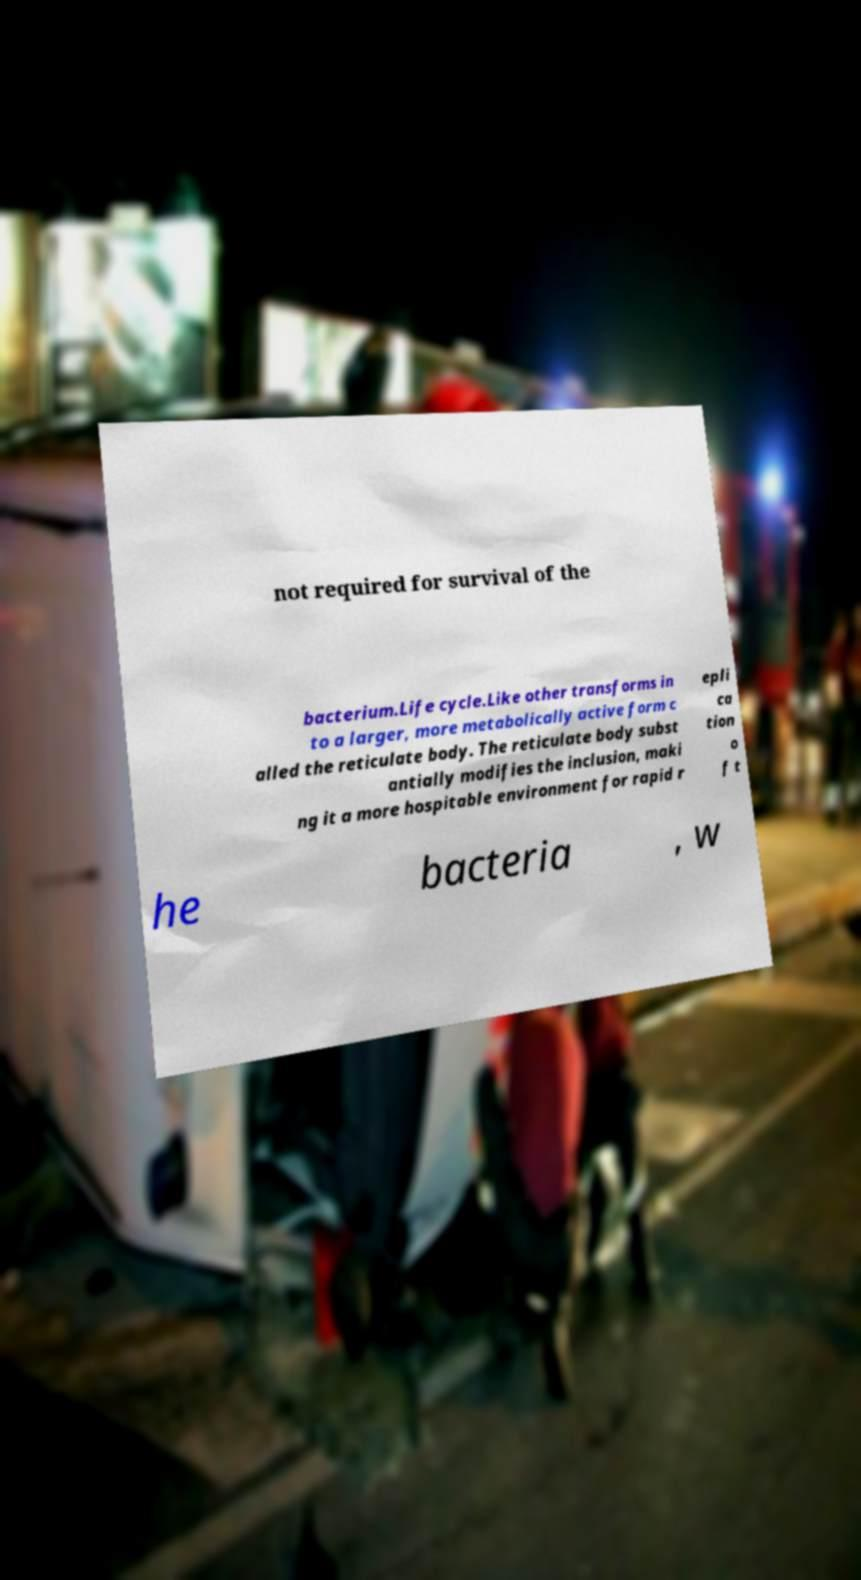Can you read and provide the text displayed in the image?This photo seems to have some interesting text. Can you extract and type it out for me? not required for survival of the bacterium.Life cycle.Like other transforms in to a larger, more metabolically active form c alled the reticulate body. The reticulate body subst antially modifies the inclusion, maki ng it a more hospitable environment for rapid r epli ca tion o f t he bacteria , w 